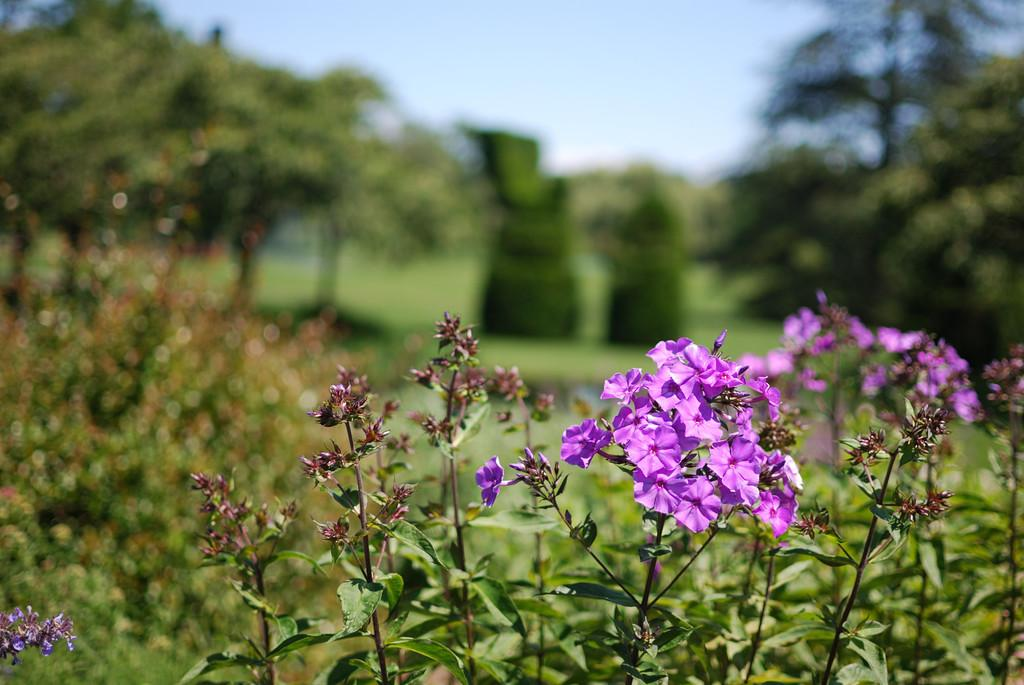What type of plant can be seen in the image? There is a purple flower plant in the image. How would you describe the background of the image? The background of the image is blurred. What can be seen in the distance in the image? There are trees visible in the background of the image. Is there a cat sitting on a swing under an umbrella in the image? No, there is no cat, swing, or umbrella present in the image. 